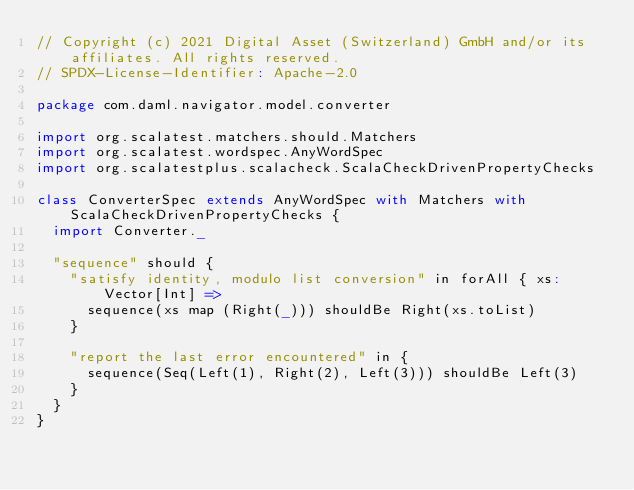Convert code to text. <code><loc_0><loc_0><loc_500><loc_500><_Scala_>// Copyright (c) 2021 Digital Asset (Switzerland) GmbH and/or its affiliates. All rights reserved.
// SPDX-License-Identifier: Apache-2.0

package com.daml.navigator.model.converter

import org.scalatest.matchers.should.Matchers
import org.scalatest.wordspec.AnyWordSpec
import org.scalatestplus.scalacheck.ScalaCheckDrivenPropertyChecks

class ConverterSpec extends AnyWordSpec with Matchers with ScalaCheckDrivenPropertyChecks {
  import Converter._

  "sequence" should {
    "satisfy identity, modulo list conversion" in forAll { xs: Vector[Int] =>
      sequence(xs map (Right(_))) shouldBe Right(xs.toList)
    }

    "report the last error encountered" in {
      sequence(Seq(Left(1), Right(2), Left(3))) shouldBe Left(3)
    }
  }
}
</code> 